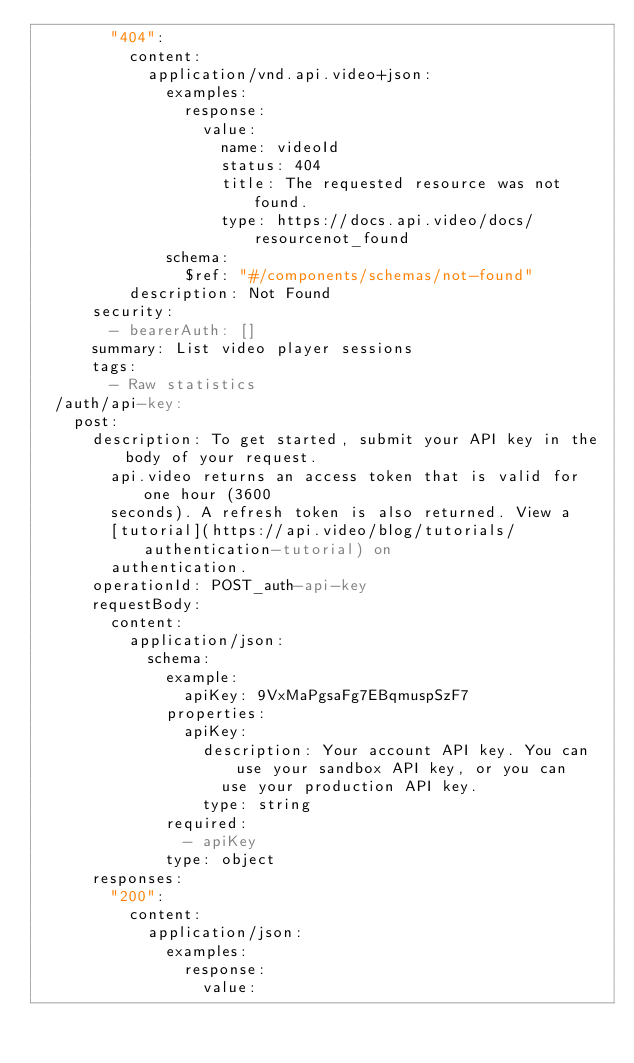<code> <loc_0><loc_0><loc_500><loc_500><_YAML_>        "404":
          content:
            application/vnd.api.video+json:
              examples:
                response:
                  value:
                    name: videoId
                    status: 404
                    title: The requested resource was not found.
                    type: https://docs.api.video/docs/resourcenot_found
              schema:
                $ref: "#/components/schemas/not-found"
          description: Not Found
      security:
        - bearerAuth: []
      summary: List video player sessions
      tags:
        - Raw statistics
  /auth/api-key:
    post:
      description: To get started, submit your API key in the body of your request.
        api.video returns an access token that is valid for one hour (3600
        seconds). A refresh token is also returned. View a
        [tutorial](https://api.video/blog/tutorials/authentication-tutorial) on
        authentication.
      operationId: POST_auth-api-key
      requestBody:
        content:
          application/json:
            schema:
              example:
                apiKey: 9VxMaPgsaFg7EBqmuspSzF7
              properties:
                apiKey:
                  description: Your account API key. You can use your sandbox API key, or you can
                    use your production API key.
                  type: string
              required:
                - apiKey
              type: object
      responses:
        "200":
          content:
            application/json:
              examples:
                response:
                  value:</code> 